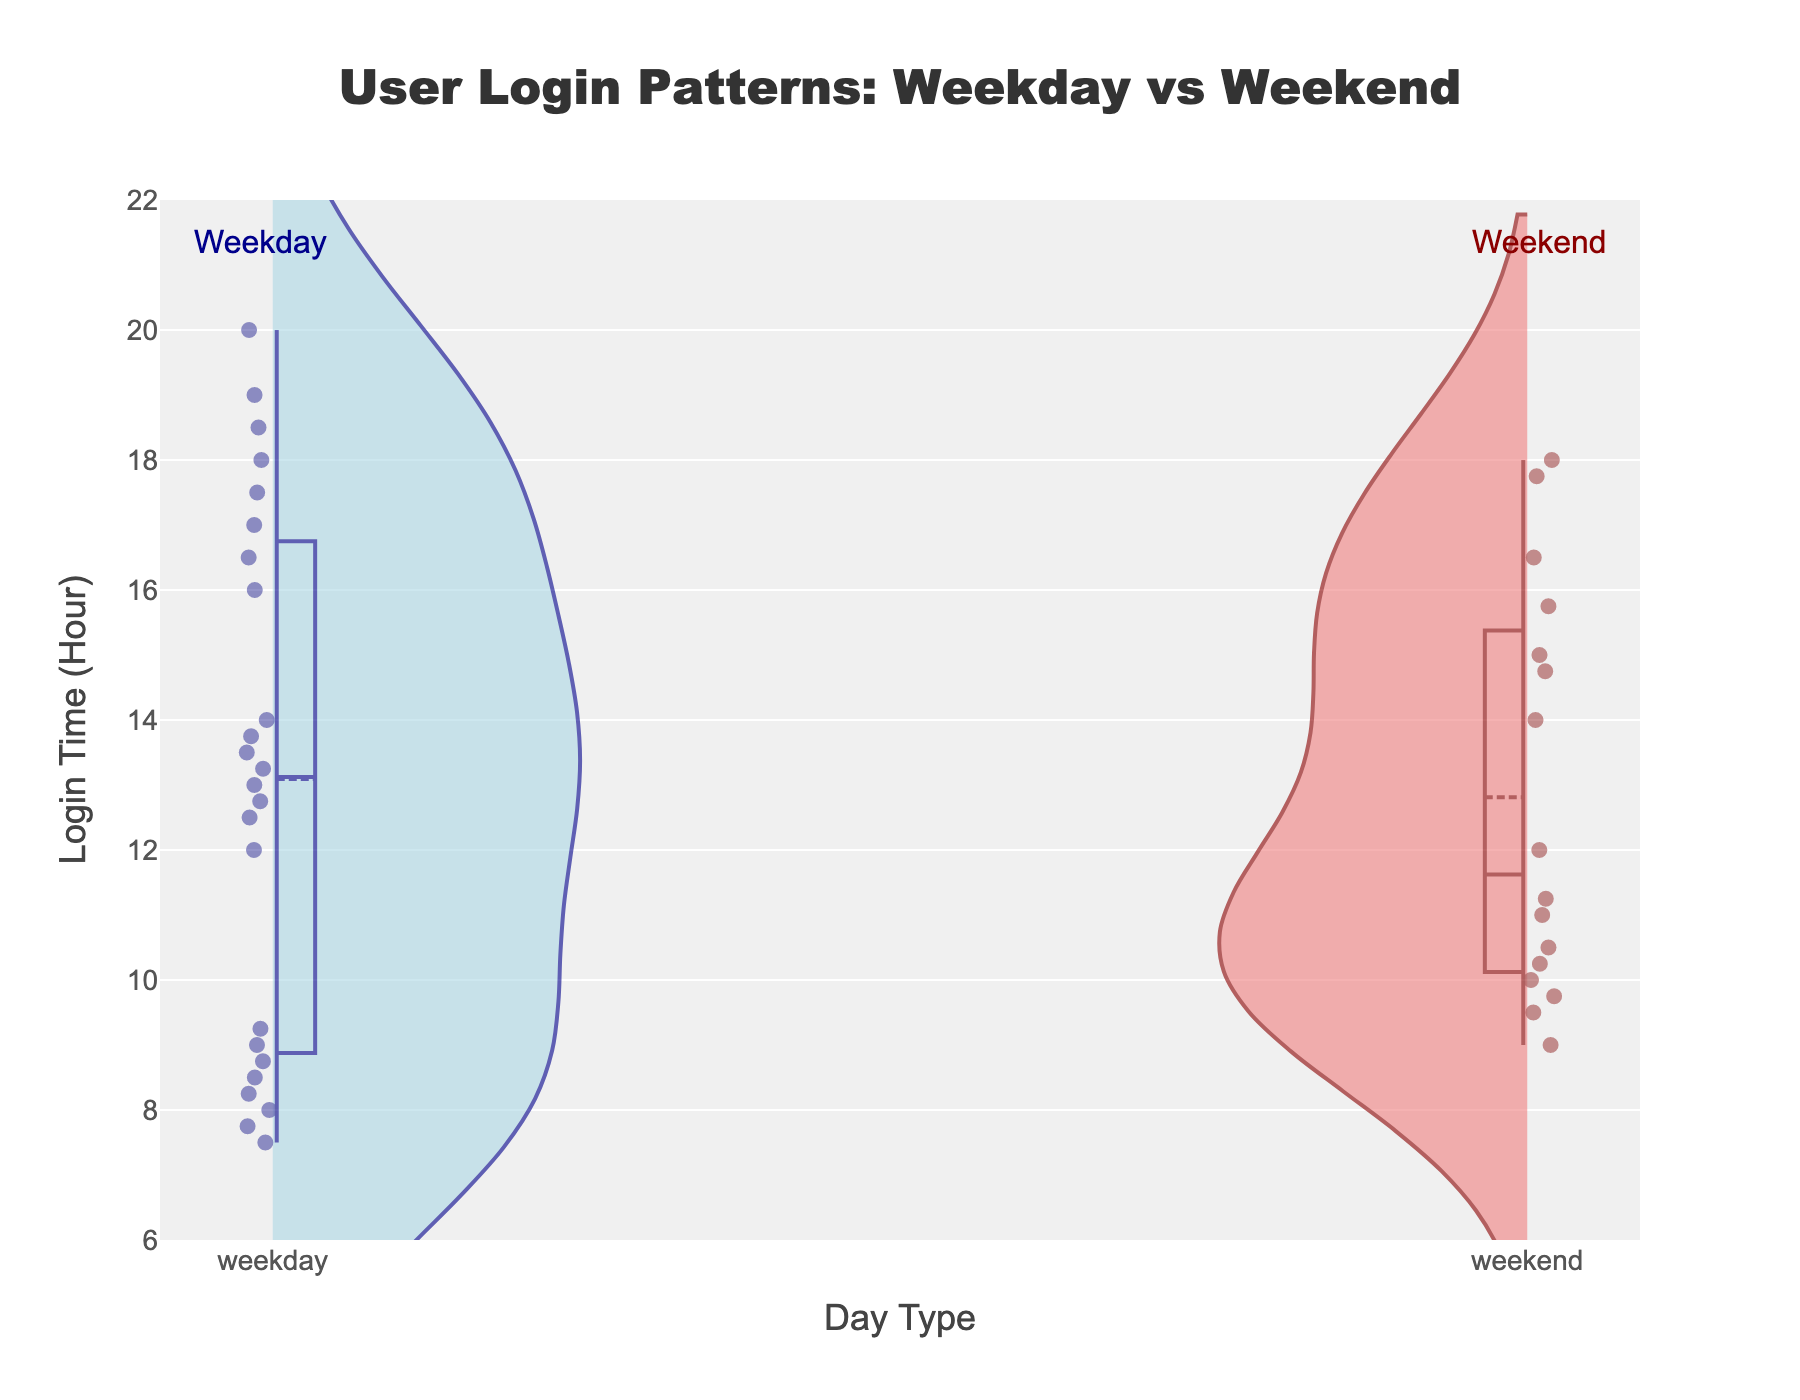What is the title of the figure? The title is found at the top of the plot. It is usually the largest text in the figure, summarizing the main topic of the data visualization.
Answer: User Login Patterns: Weekday vs Weekend Which day type has a login peak earlier in the day? Look at the distribution of the login times denoted by the density shape. The weekday login times peak earlier compared to the weekend login times, which are more spread out and peak later.
Answer: Weekday Between what hours does the weekday distribution show the highest density of logins? Observe the width and height of the violin plot for weekdays. The density is highest where the plot is widest. This happens between around 12 PM and 2 PM.
Answer: 12 PM to 2 PM Are there any login times later than 8 PM? Check the distribution shape on the y-axis for both weekday and weekend. The data points extend up to 8 PM but not beyond.
Answer: No What are the mean login times for weekdays and weekends? The mean login times are shown by the horizontal line within the violin plots. For weekdays, the mean is around midday (12 PM), and for weekends, it's around 3 PM.
Answer: Weekday: 12 PM; Weekend: 3 PM Where is the spread of login times larger, on weekdays or weekends? Compare the widths of the two violin plots. The spread is indicated by the total horizontal extent. The weekend plot is wider, indicating a larger spread.
Answer: Weekend How does the log in distribution compare between early morning (6 AM to 10 AM) on weekdays and weekends? Look at the violin plots between 6 AM and 10 AM on the y-axis. Weekdays show a higher density of logins within this time frame compared to weekends.
Answer: Higher on weekdays Which day type has more tightly clustered login times around the mean? Check the density of both violin plots close to their means. The weekday login times are more tightly clustered around noon, whereas weekend times are more spread out.
Answer: Weekday What color represents the weekend login data in the violin plot? The visual attributes of the figure can be used to identify colors. The weekend is represented by a light red color.
Answer: Light red Between 2 PM and 6 PM, which day type shows more login density? Look at the violin plot sections from 2 PM to 6 PM. The weekend plot shows more density (wider shape) during these hours.
Answer: Weekend 